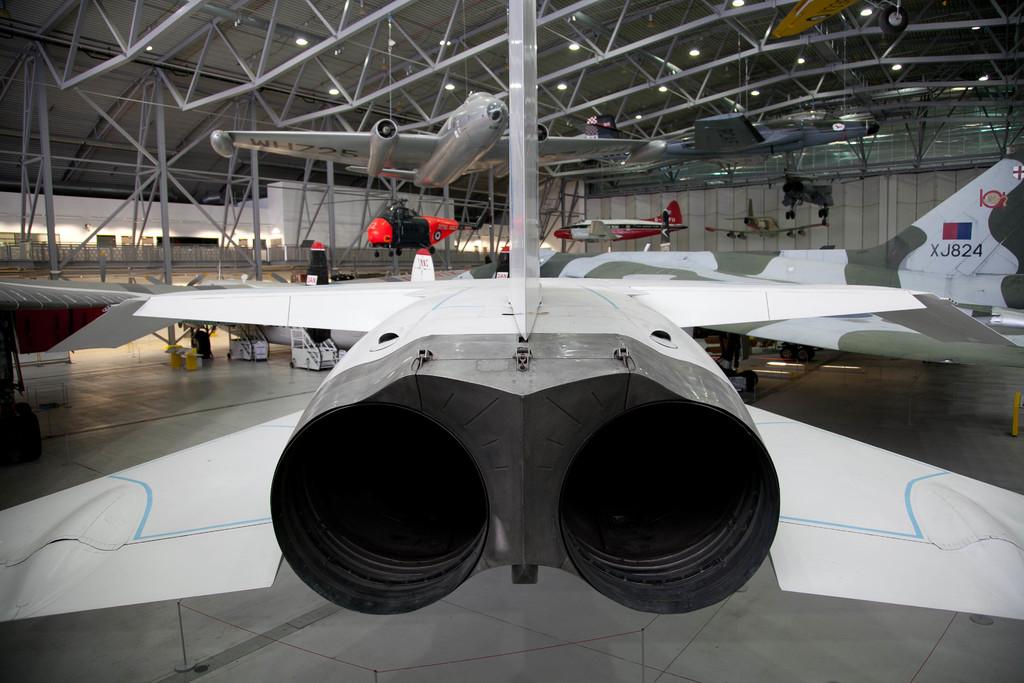What aircraft id code is shown on the right?
Ensure brevity in your answer.  Xj824. 